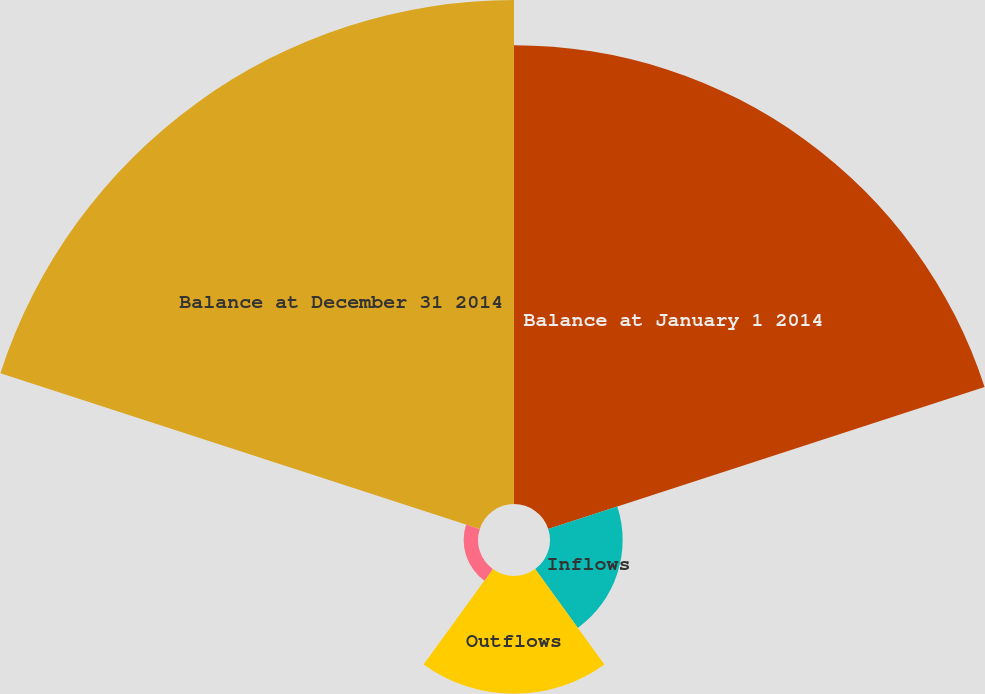Convert chart. <chart><loc_0><loc_0><loc_500><loc_500><pie_chart><fcel>Balance at January 1 2014<fcel>Inflows<fcel>Outflows<fcel>Market (depreciation)<fcel>Balance at December 31 2014<nl><fcel>39.29%<fcel>6.22%<fcel>10.09%<fcel>1.23%<fcel>43.16%<nl></chart> 